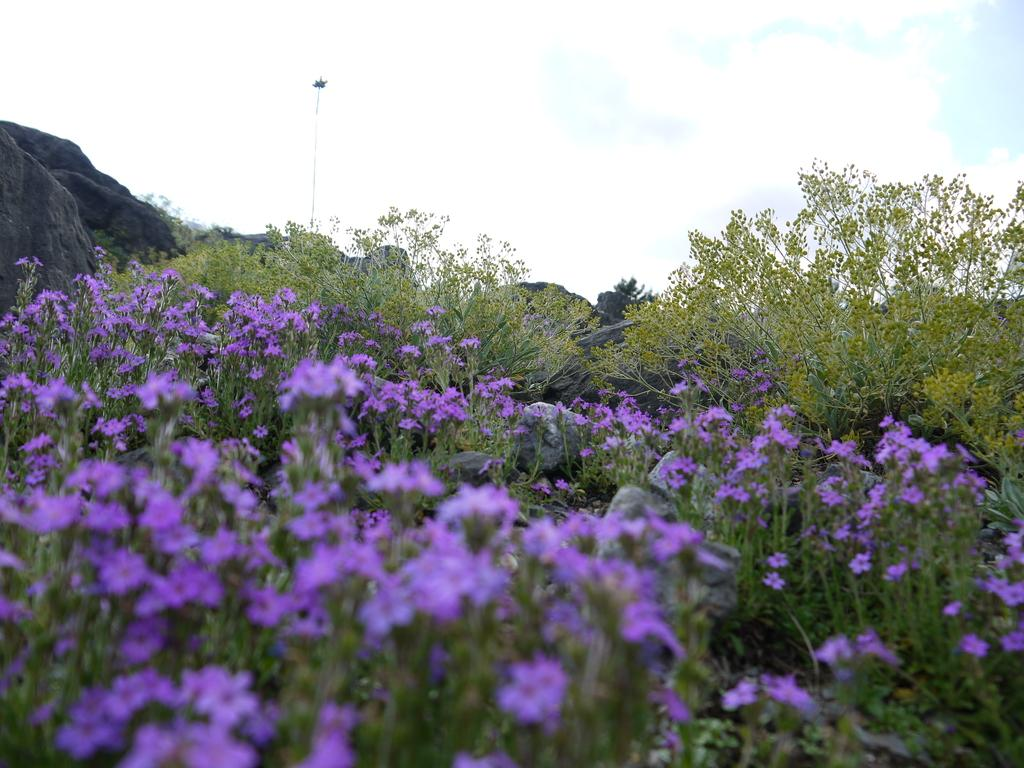What types of living organisms can be seen in the image? Plants and flowers are visible in the image. What other elements can be seen in the image? There are rocks in the background of the image. What is visible in the sky in the image? The sky is visible in the background of the image. Can you tell me how many cows are grazing in the image? There are no cows present in the image; it features plants, flowers, rocks, and the sky. What type of ear is visible on the mother in the image? There is no mother or ear present in the image. 